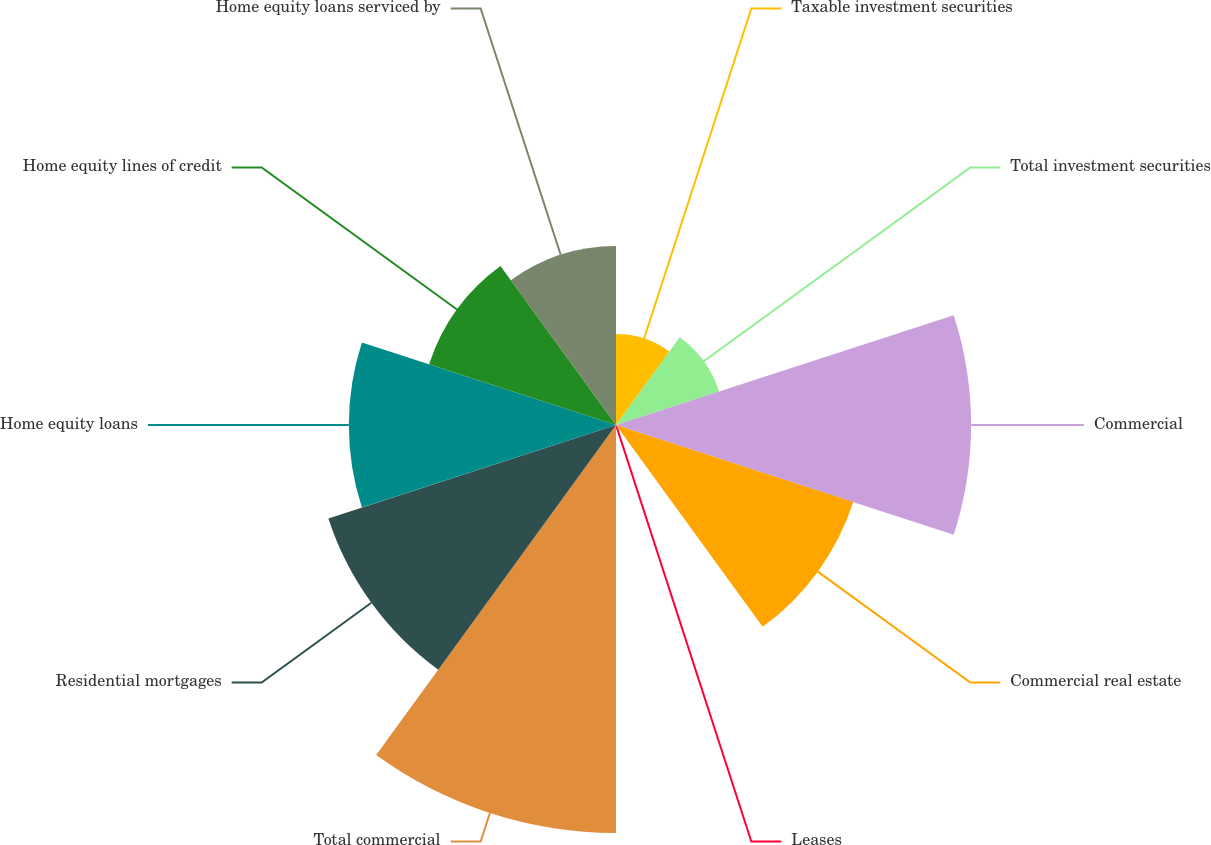<chart> <loc_0><loc_0><loc_500><loc_500><pie_chart><fcel>Taxable investment securities<fcel>Total investment securities<fcel>Commercial<fcel>Commercial real estate<fcel>Leases<fcel>Total commercial<fcel>Residential mortgages<fcel>Home equity loans<fcel>Home equity lines of credit<fcel>Home equity loans serviced by<nl><fcel>4.21%<fcel>5.02%<fcel>16.44%<fcel>11.55%<fcel>0.13%<fcel>18.89%<fcel>14.0%<fcel>12.37%<fcel>9.1%<fcel>8.29%<nl></chart> 